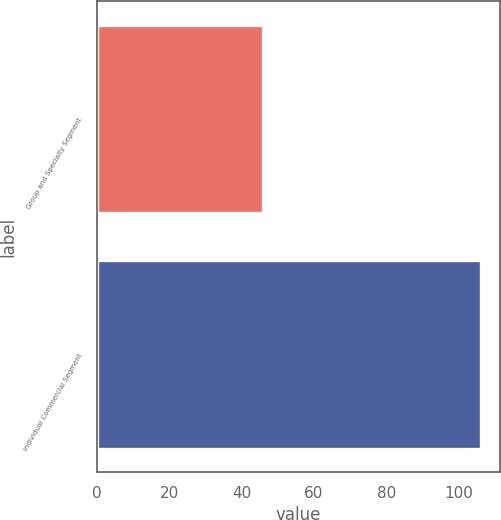Convert chart. <chart><loc_0><loc_0><loc_500><loc_500><bar_chart><fcel>Group and Specialty Segment<fcel>Individual Commercial Segment<nl><fcel>46<fcel>106<nl></chart> 